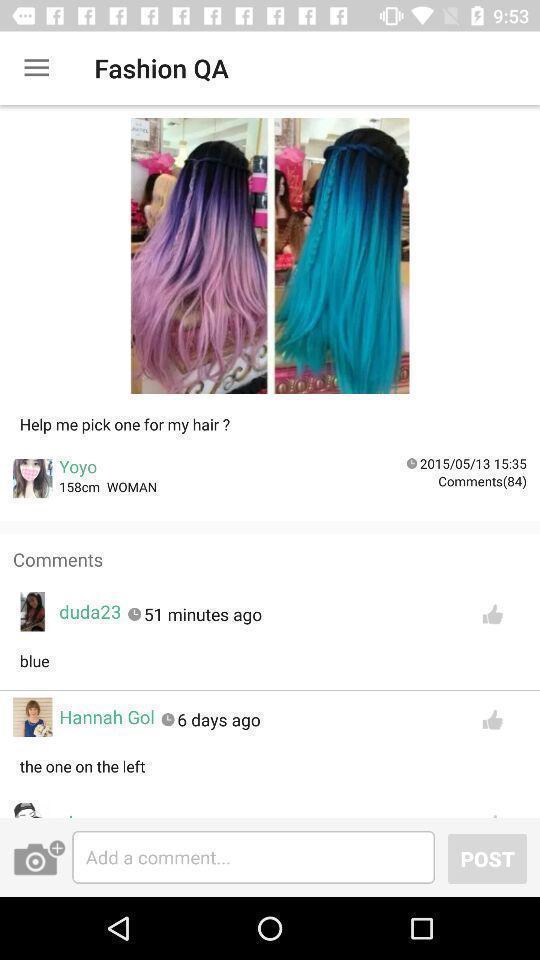Give me a narrative description of this picture. Screen displaying the comments page. 